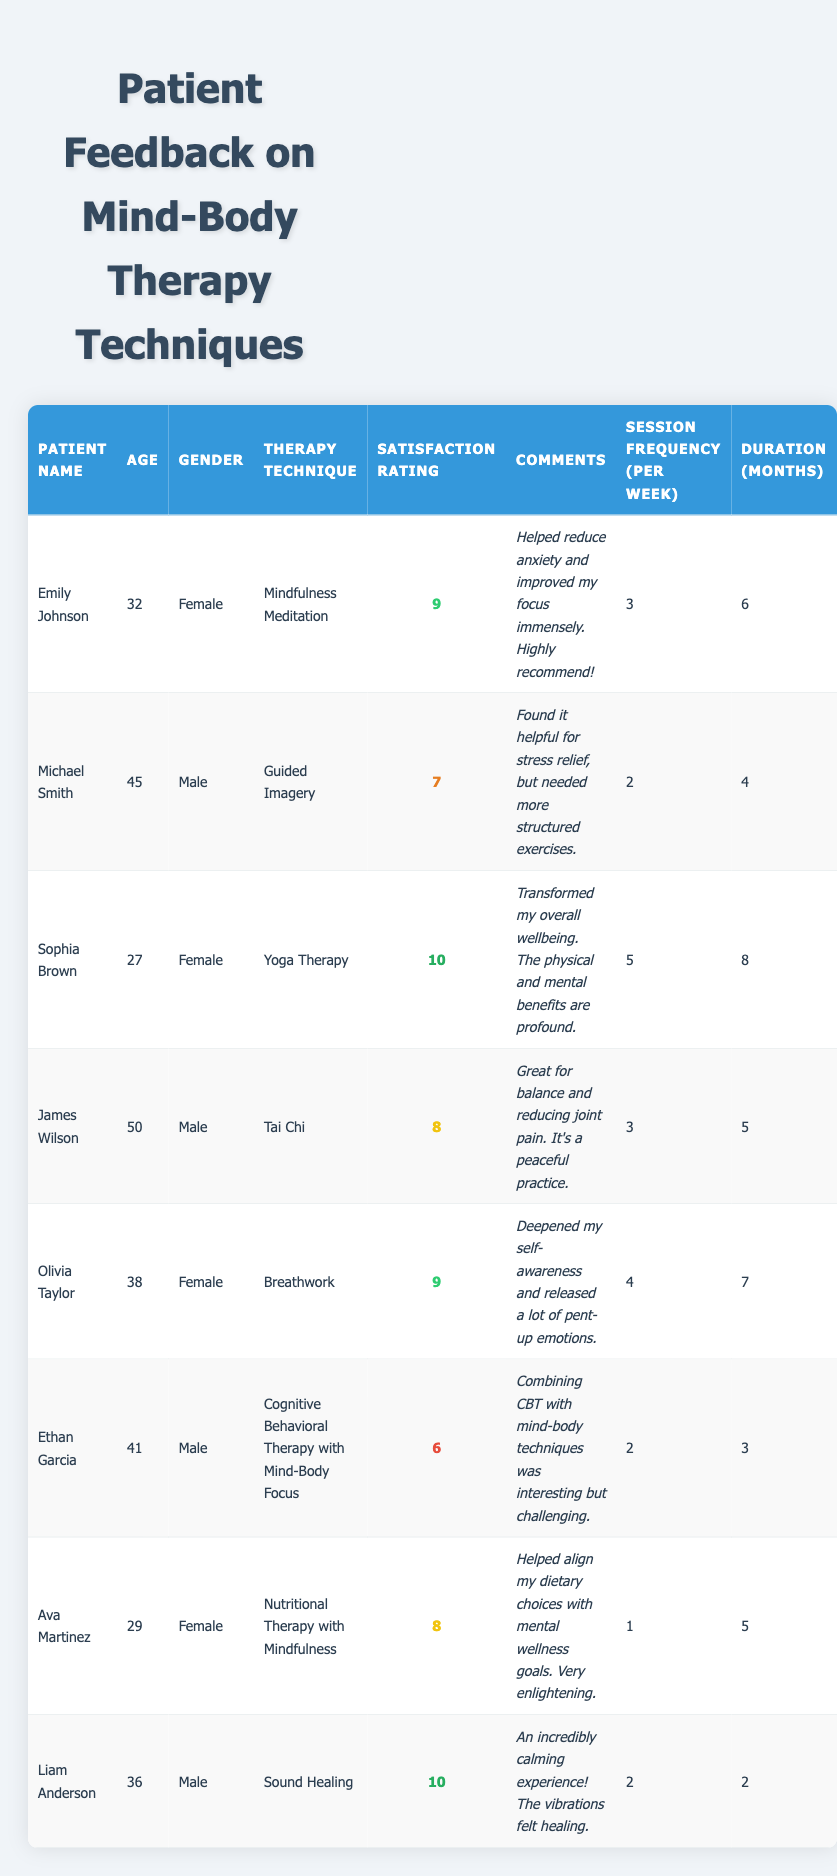What therapy technique received the highest satisfaction rating? From the table, "Yoga Therapy" and "Sound Healing" both received a satisfaction rating of 10, which is the highest rating.
Answer: Yoga Therapy and Sound Healing How many weeks did Emily Johnson undergo therapy? Emily Johnson had therapy for 6 months, and with sessions occurring 3 times a week, this means she participated for approximately 6 * 4 (weeks per month) = 24 weeks.
Answer: 24 weeks What is the average satisfaction rating of all patients? To find the average, first sum up the satisfaction ratings: 9 + 7 + 10 + 8 + 9 + 6 + 8 + 10 = 67. There are 8 patients, so the average is 67 / 8 = 8.375.
Answer: 8.375 Did any patient mention an improvement in anxiety? Yes, Emily Johnson's comments specifically mention a reduction in anxiety due to the technique she practiced.
Answer: Yes Who practiced a therapy technique for the shortest duration? Liam Anderson practiced Sound Healing for 2 months, which is the shortest duration compared to other patients in the table.
Answer: Liam Anderson Is there any male patient who scored lower than 7 in satisfaction? Yes, Ethan Garcia scored 6 in satisfaction, which is lower than 7.
Answer: Yes What is the session frequency of the patient with the highest satisfaction rating? The highest satisfaction rating of 10 was given to both Sophia Brown and Liam Anderson. Sophia practiced 5 sessions per week, while Liam practiced 2 sessions per week.
Answer: 5 and 2 sessions per week How does Olivia Taylor's satisfaction rating compare to that of Ethan Garcia? Olivia Taylor has a satisfaction rating of 9, while Ethan Garcia has a rating of 6. Since 9 is greater than 6, Olivia's rating is higher.
Answer: Higher What percentage of patients practiced Mindfulness-based techniques? The patients using mindfulness techniques included Emily Johnson, Olivia Taylor, Ava Martinez, and Liam Anderson, totaling 4 patients out of 8. The percentage is (4 / 8) * 100 = 50%.
Answer: 50% Are there any patients younger than 30 who reported significant improvements? Yes, Sophia Brown, who is 27, reported significant improvements in her wellbeing from Yoga Therapy.
Answer: Yes 